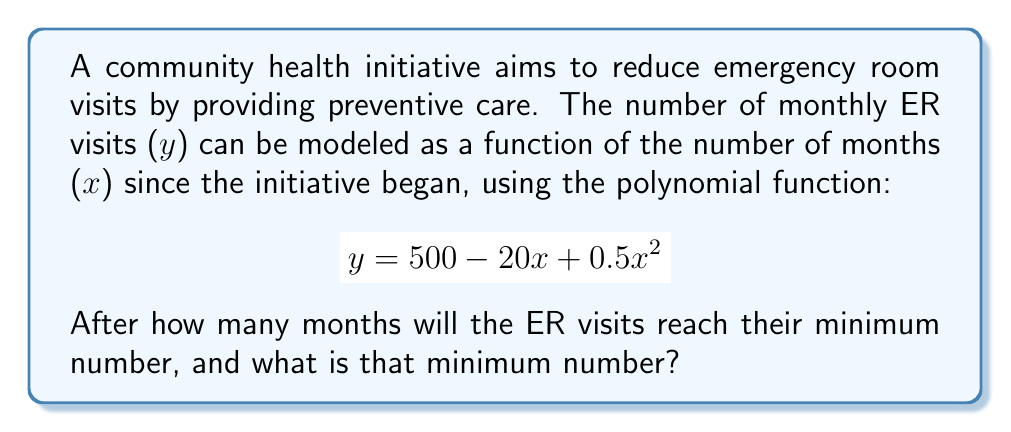Give your solution to this math problem. To find the minimum number of ER visits and when it occurs, we need to follow these steps:

1) The given function is a quadratic polynomial:
   $$ y = 500 - 20x + 0.5x^2 $$

2) For a quadratic function $f(x) = ax^2 + bx + c$, the vertex occurs at $x = -\frac{b}{2a}$, which gives the x-coordinate of the minimum point when $a > 0$.

3) In our case, $a = 0.5$, $b = -20$, and $c = 500$. Let's calculate $x$:

   $$ x = -\frac{b}{2a} = -\frac{-20}{2(0.5)} = \frac{20}{1} = 20 $$

4) This means the minimum occurs 20 months after the initiative began.

5) To find the minimum number of ER visits, we substitute $x = 20$ into the original function:

   $$ y = 500 - 20(20) + 0.5(20)^2 $$
   $$ y = 500 - 400 + 0.5(400) $$
   $$ y = 500 - 400 + 200 = 300 $$

Therefore, the minimum number of ER visits is 300, occurring 20 months after the initiative began.
Answer: 20 months; 300 visits 